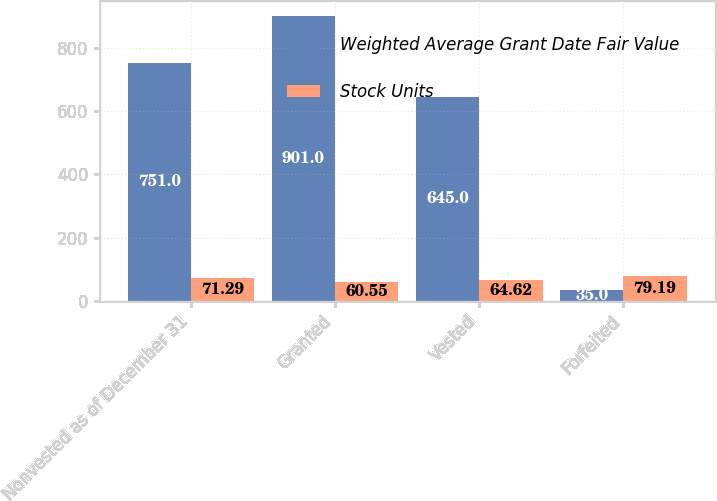<chart> <loc_0><loc_0><loc_500><loc_500><stacked_bar_chart><ecel><fcel>Nonvested as of December 31<fcel>Granted<fcel>Vested<fcel>Forfeited<nl><fcel>Weighted Average Grant Date Fair Value<fcel>751<fcel>901<fcel>645<fcel>35<nl><fcel>Stock Units<fcel>71.29<fcel>60.55<fcel>64.62<fcel>79.19<nl></chart> 